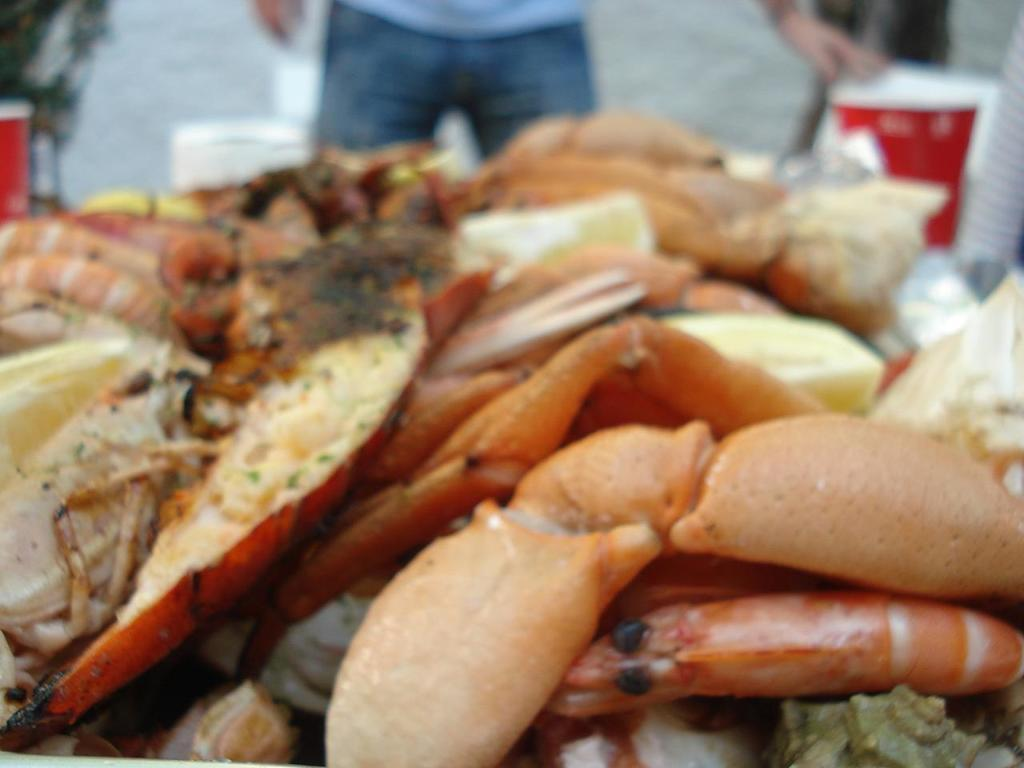What type of food is present in the image? There is seafood in the image. Can you describe the setting or context of the image? There are people in the background of the image. What type of steel is used to construct the veins in the image? There is no steel or veins present in the image; it features seafood and people in the background. 